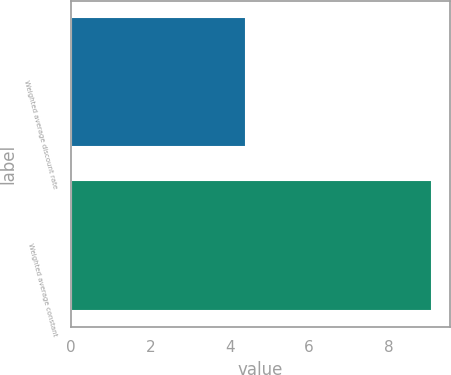Convert chart. <chart><loc_0><loc_0><loc_500><loc_500><bar_chart><fcel>Weighted average discount rate<fcel>Weighted average constant<nl><fcel>4.4<fcel>9.1<nl></chart> 